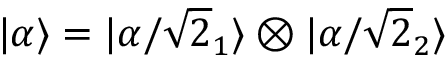<formula> <loc_0><loc_0><loc_500><loc_500>| \alpha \rangle = | \alpha / { \sqrt { 2 } } _ { 1 } \rangle \otimes | \alpha / { \sqrt { 2 } } _ { 2 } \rangle</formula> 